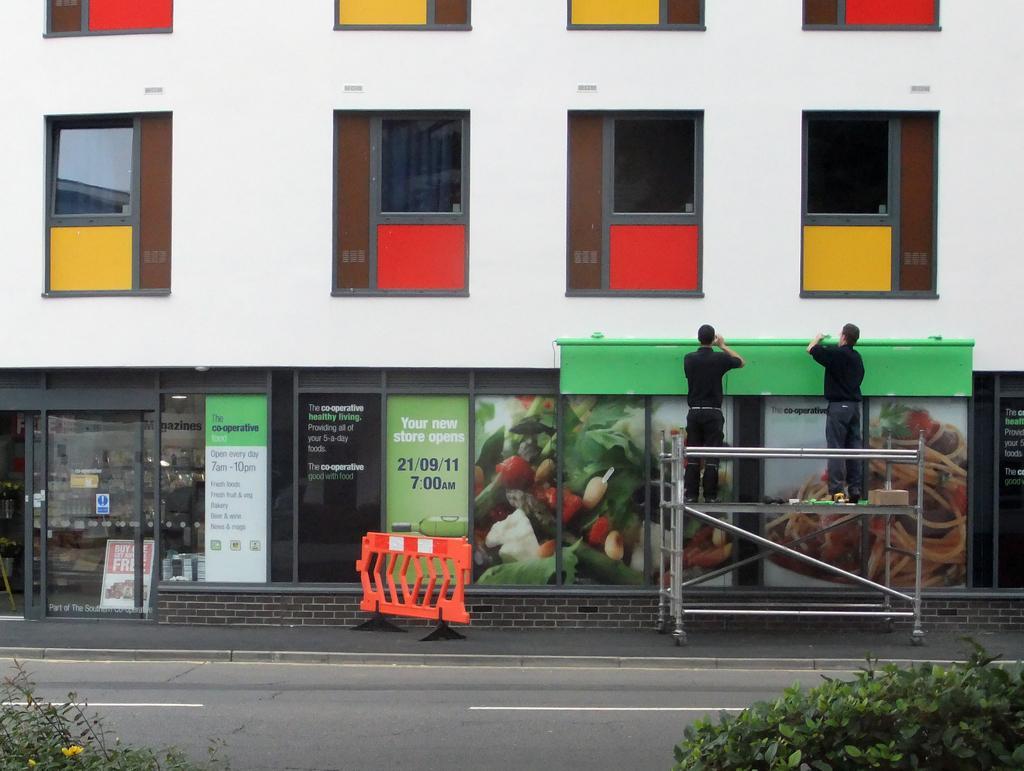Describe this image in one or two sentences. In this picture we can see the entrance of a store with glass doors and windows. There are 2 people standing on the ladder and fixing a green board in front of the store. Here we can see an orange barricade, the road and plants. 